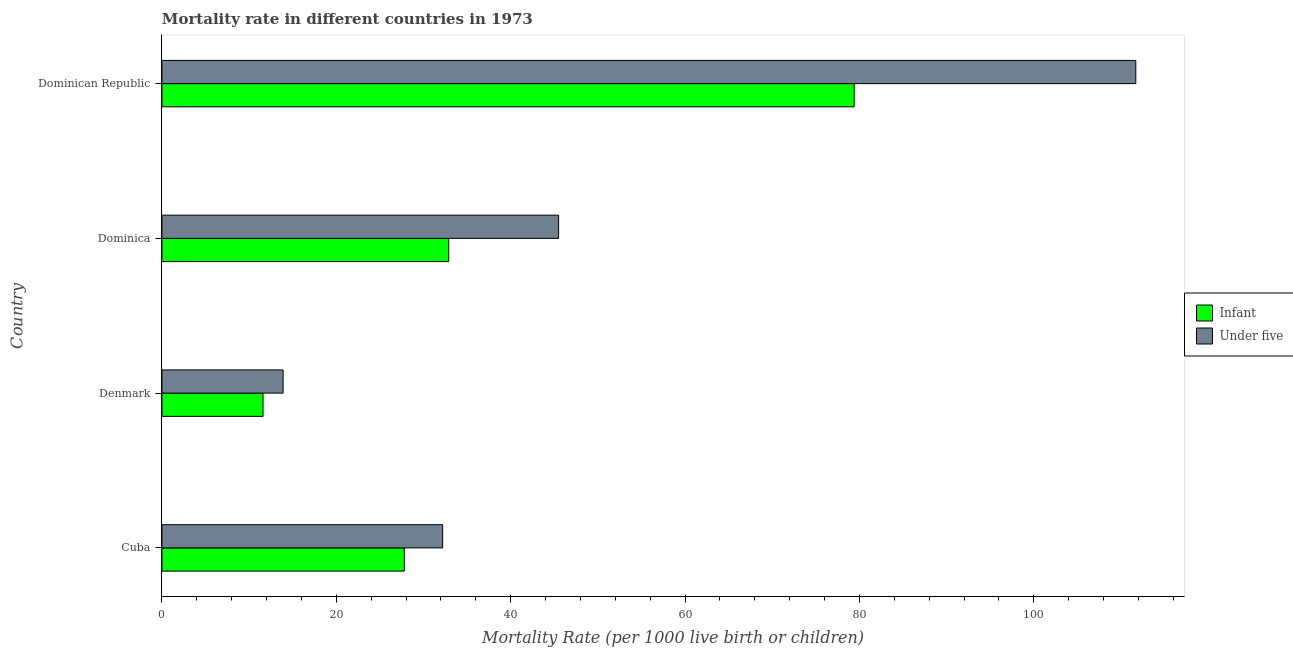How many different coloured bars are there?
Provide a succinct answer. 2. How many bars are there on the 3rd tick from the top?
Your answer should be very brief. 2. What is the label of the 2nd group of bars from the top?
Your answer should be very brief. Dominica. What is the infant mortality rate in Dominica?
Provide a succinct answer. 32.9. Across all countries, what is the maximum infant mortality rate?
Give a very brief answer. 79.4. In which country was the under-5 mortality rate maximum?
Provide a succinct answer. Dominican Republic. In which country was the under-5 mortality rate minimum?
Your answer should be very brief. Denmark. What is the total under-5 mortality rate in the graph?
Your answer should be compact. 203.3. What is the difference between the under-5 mortality rate in Cuba and that in Dominican Republic?
Ensure brevity in your answer.  -79.5. What is the difference between the under-5 mortality rate in Denmark and the infant mortality rate in Dominica?
Provide a succinct answer. -19. What is the average under-5 mortality rate per country?
Keep it short and to the point. 50.83. What is the difference between the under-5 mortality rate and infant mortality rate in Dominican Republic?
Offer a very short reply. 32.3. In how many countries, is the infant mortality rate greater than 48 ?
Make the answer very short. 1. What is the ratio of the under-5 mortality rate in Denmark to that in Dominican Republic?
Make the answer very short. 0.12. What is the difference between the highest and the second highest infant mortality rate?
Your answer should be very brief. 46.5. What is the difference between the highest and the lowest infant mortality rate?
Offer a very short reply. 67.8. Is the sum of the under-5 mortality rate in Dominica and Dominican Republic greater than the maximum infant mortality rate across all countries?
Your answer should be compact. Yes. What does the 2nd bar from the top in Denmark represents?
Your answer should be compact. Infant. What does the 2nd bar from the bottom in Dominican Republic represents?
Your answer should be very brief. Under five. How many bars are there?
Offer a very short reply. 8. Are the values on the major ticks of X-axis written in scientific E-notation?
Keep it short and to the point. No. Does the graph contain any zero values?
Your response must be concise. No. Where does the legend appear in the graph?
Provide a succinct answer. Center right. What is the title of the graph?
Provide a succinct answer. Mortality rate in different countries in 1973. Does "Domestic liabilities" appear as one of the legend labels in the graph?
Give a very brief answer. No. What is the label or title of the X-axis?
Your answer should be compact. Mortality Rate (per 1000 live birth or children). What is the Mortality Rate (per 1000 live birth or children) in Infant in Cuba?
Your answer should be very brief. 27.8. What is the Mortality Rate (per 1000 live birth or children) in Under five in Cuba?
Keep it short and to the point. 32.2. What is the Mortality Rate (per 1000 live birth or children) of Infant in Denmark?
Provide a short and direct response. 11.6. What is the Mortality Rate (per 1000 live birth or children) in Infant in Dominica?
Keep it short and to the point. 32.9. What is the Mortality Rate (per 1000 live birth or children) of Under five in Dominica?
Your answer should be very brief. 45.5. What is the Mortality Rate (per 1000 live birth or children) of Infant in Dominican Republic?
Give a very brief answer. 79.4. What is the Mortality Rate (per 1000 live birth or children) in Under five in Dominican Republic?
Provide a succinct answer. 111.7. Across all countries, what is the maximum Mortality Rate (per 1000 live birth or children) in Infant?
Your answer should be very brief. 79.4. Across all countries, what is the maximum Mortality Rate (per 1000 live birth or children) of Under five?
Make the answer very short. 111.7. Across all countries, what is the minimum Mortality Rate (per 1000 live birth or children) in Under five?
Keep it short and to the point. 13.9. What is the total Mortality Rate (per 1000 live birth or children) of Infant in the graph?
Keep it short and to the point. 151.7. What is the total Mortality Rate (per 1000 live birth or children) of Under five in the graph?
Your answer should be very brief. 203.3. What is the difference between the Mortality Rate (per 1000 live birth or children) of Infant in Cuba and that in Denmark?
Provide a succinct answer. 16.2. What is the difference between the Mortality Rate (per 1000 live birth or children) in Infant in Cuba and that in Dominica?
Provide a short and direct response. -5.1. What is the difference between the Mortality Rate (per 1000 live birth or children) in Infant in Cuba and that in Dominican Republic?
Ensure brevity in your answer.  -51.6. What is the difference between the Mortality Rate (per 1000 live birth or children) of Under five in Cuba and that in Dominican Republic?
Your answer should be compact. -79.5. What is the difference between the Mortality Rate (per 1000 live birth or children) in Infant in Denmark and that in Dominica?
Keep it short and to the point. -21.3. What is the difference between the Mortality Rate (per 1000 live birth or children) in Under five in Denmark and that in Dominica?
Keep it short and to the point. -31.6. What is the difference between the Mortality Rate (per 1000 live birth or children) in Infant in Denmark and that in Dominican Republic?
Provide a short and direct response. -67.8. What is the difference between the Mortality Rate (per 1000 live birth or children) in Under five in Denmark and that in Dominican Republic?
Ensure brevity in your answer.  -97.8. What is the difference between the Mortality Rate (per 1000 live birth or children) of Infant in Dominica and that in Dominican Republic?
Offer a terse response. -46.5. What is the difference between the Mortality Rate (per 1000 live birth or children) in Under five in Dominica and that in Dominican Republic?
Your answer should be compact. -66.2. What is the difference between the Mortality Rate (per 1000 live birth or children) in Infant in Cuba and the Mortality Rate (per 1000 live birth or children) in Under five in Denmark?
Your response must be concise. 13.9. What is the difference between the Mortality Rate (per 1000 live birth or children) of Infant in Cuba and the Mortality Rate (per 1000 live birth or children) of Under five in Dominica?
Offer a very short reply. -17.7. What is the difference between the Mortality Rate (per 1000 live birth or children) in Infant in Cuba and the Mortality Rate (per 1000 live birth or children) in Under five in Dominican Republic?
Provide a short and direct response. -83.9. What is the difference between the Mortality Rate (per 1000 live birth or children) in Infant in Denmark and the Mortality Rate (per 1000 live birth or children) in Under five in Dominica?
Your response must be concise. -33.9. What is the difference between the Mortality Rate (per 1000 live birth or children) in Infant in Denmark and the Mortality Rate (per 1000 live birth or children) in Under five in Dominican Republic?
Give a very brief answer. -100.1. What is the difference between the Mortality Rate (per 1000 live birth or children) of Infant in Dominica and the Mortality Rate (per 1000 live birth or children) of Under five in Dominican Republic?
Keep it short and to the point. -78.8. What is the average Mortality Rate (per 1000 live birth or children) in Infant per country?
Offer a very short reply. 37.92. What is the average Mortality Rate (per 1000 live birth or children) of Under five per country?
Keep it short and to the point. 50.83. What is the difference between the Mortality Rate (per 1000 live birth or children) in Infant and Mortality Rate (per 1000 live birth or children) in Under five in Denmark?
Ensure brevity in your answer.  -2.3. What is the difference between the Mortality Rate (per 1000 live birth or children) of Infant and Mortality Rate (per 1000 live birth or children) of Under five in Dominica?
Offer a very short reply. -12.6. What is the difference between the Mortality Rate (per 1000 live birth or children) of Infant and Mortality Rate (per 1000 live birth or children) of Under five in Dominican Republic?
Ensure brevity in your answer.  -32.3. What is the ratio of the Mortality Rate (per 1000 live birth or children) in Infant in Cuba to that in Denmark?
Provide a short and direct response. 2.4. What is the ratio of the Mortality Rate (per 1000 live birth or children) of Under five in Cuba to that in Denmark?
Provide a short and direct response. 2.32. What is the ratio of the Mortality Rate (per 1000 live birth or children) in Infant in Cuba to that in Dominica?
Provide a succinct answer. 0.84. What is the ratio of the Mortality Rate (per 1000 live birth or children) of Under five in Cuba to that in Dominica?
Make the answer very short. 0.71. What is the ratio of the Mortality Rate (per 1000 live birth or children) of Infant in Cuba to that in Dominican Republic?
Your answer should be very brief. 0.35. What is the ratio of the Mortality Rate (per 1000 live birth or children) of Under five in Cuba to that in Dominican Republic?
Offer a very short reply. 0.29. What is the ratio of the Mortality Rate (per 1000 live birth or children) of Infant in Denmark to that in Dominica?
Ensure brevity in your answer.  0.35. What is the ratio of the Mortality Rate (per 1000 live birth or children) of Under five in Denmark to that in Dominica?
Your answer should be compact. 0.31. What is the ratio of the Mortality Rate (per 1000 live birth or children) in Infant in Denmark to that in Dominican Republic?
Offer a terse response. 0.15. What is the ratio of the Mortality Rate (per 1000 live birth or children) in Under five in Denmark to that in Dominican Republic?
Make the answer very short. 0.12. What is the ratio of the Mortality Rate (per 1000 live birth or children) of Infant in Dominica to that in Dominican Republic?
Provide a short and direct response. 0.41. What is the ratio of the Mortality Rate (per 1000 live birth or children) in Under five in Dominica to that in Dominican Republic?
Keep it short and to the point. 0.41. What is the difference between the highest and the second highest Mortality Rate (per 1000 live birth or children) of Infant?
Offer a very short reply. 46.5. What is the difference between the highest and the second highest Mortality Rate (per 1000 live birth or children) of Under five?
Your answer should be very brief. 66.2. What is the difference between the highest and the lowest Mortality Rate (per 1000 live birth or children) of Infant?
Keep it short and to the point. 67.8. What is the difference between the highest and the lowest Mortality Rate (per 1000 live birth or children) of Under five?
Your response must be concise. 97.8. 